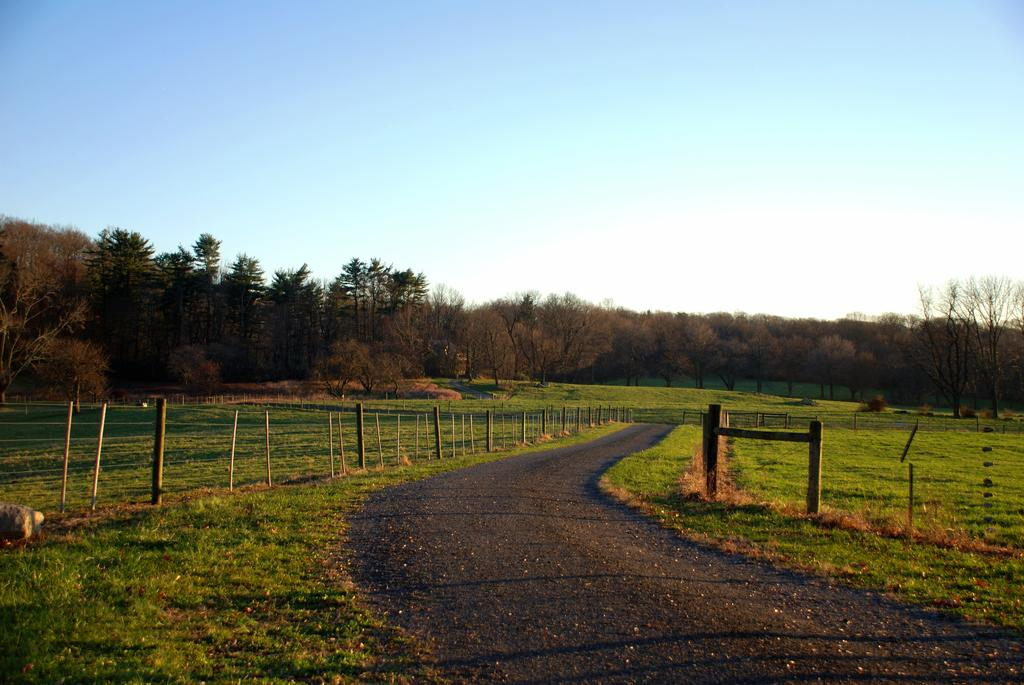What type of vegetation can be seen in the image? There are trees, plants, and grass visible in the image. What other objects can be seen in the image? There are rocks and wooden poles visible in the image. What is visible in the background of the image? The sky is visible in the image. What type of paste is used to hold the nation together in the image? There is no mention of a nation or paste in the image; it features trees, plants, grass, rocks, wooden poles, and the sky. 